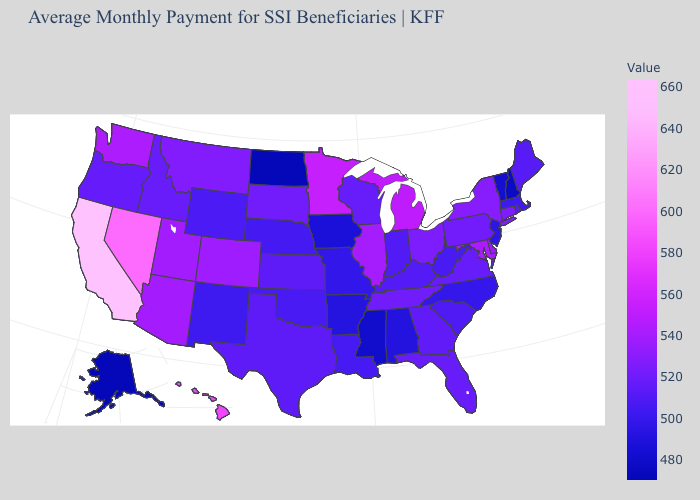Among the states that border Pennsylvania , does New Jersey have the lowest value?
Quick response, please. Yes. Among the states that border New Hampshire , which have the highest value?
Give a very brief answer. Maine. Among the states that border West Virginia , which have the lowest value?
Be succinct. Kentucky. Does Alaska have a higher value than Rhode Island?
Answer briefly. No. Which states have the highest value in the USA?
Be succinct. California. Among the states that border Oklahoma , does Colorado have the highest value?
Answer briefly. Yes. 